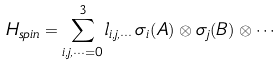Convert formula to latex. <formula><loc_0><loc_0><loc_500><loc_500>H _ { s p i n } = \sum _ { i , j , \cdots = 0 } ^ { 3 } l _ { i , j , \cdots } \, \sigma _ { i } ( A ) \otimes \sigma _ { j } ( B ) \otimes \cdots</formula> 